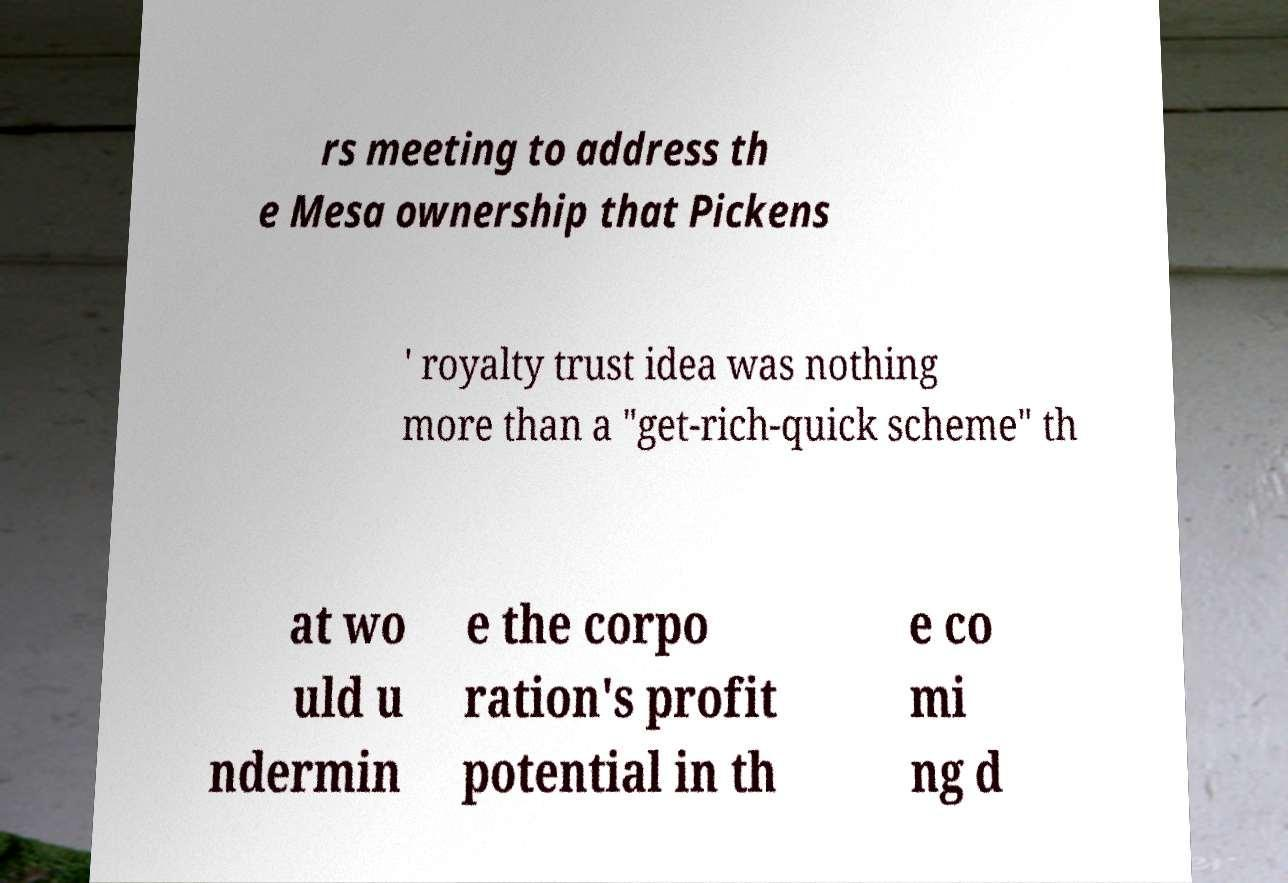There's text embedded in this image that I need extracted. Can you transcribe it verbatim? rs meeting to address th e Mesa ownership that Pickens ' royalty trust idea was nothing more than a "get-rich-quick scheme" th at wo uld u ndermin e the corpo ration's profit potential in th e co mi ng d 